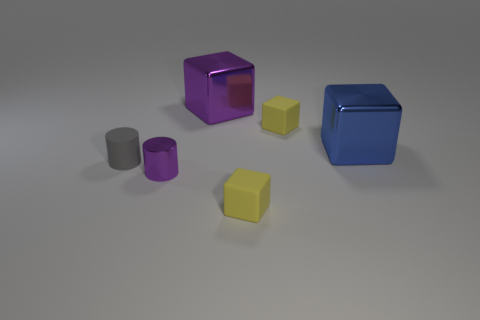How many shiny things are brown cylinders or purple blocks?
Make the answer very short. 1. Is there a small matte cylinder in front of the yellow thing that is in front of the tiny metal cylinder?
Your response must be concise. No. What number of things are either shiny objects that are behind the tiny gray cylinder or yellow cubes behind the blue metal cube?
Give a very brief answer. 3. Is there any other thing that is the same color as the rubber cylinder?
Ensure brevity in your answer.  No. The big cube behind the tiny yellow matte object behind the cylinder in front of the small gray thing is what color?
Keep it short and to the point. Purple. There is a shiny object left of the purple metallic thing on the right side of the tiny purple shiny thing; what is its size?
Give a very brief answer. Small. There is a thing that is both left of the big purple metal object and to the right of the gray rubber cylinder; what is its material?
Give a very brief answer. Metal. There is a rubber cylinder; is its size the same as the cube in front of the shiny cylinder?
Make the answer very short. Yes. Are any big brown matte spheres visible?
Provide a short and direct response. No. What is the material of the other thing that is the same shape as the tiny purple metal object?
Keep it short and to the point. Rubber. 